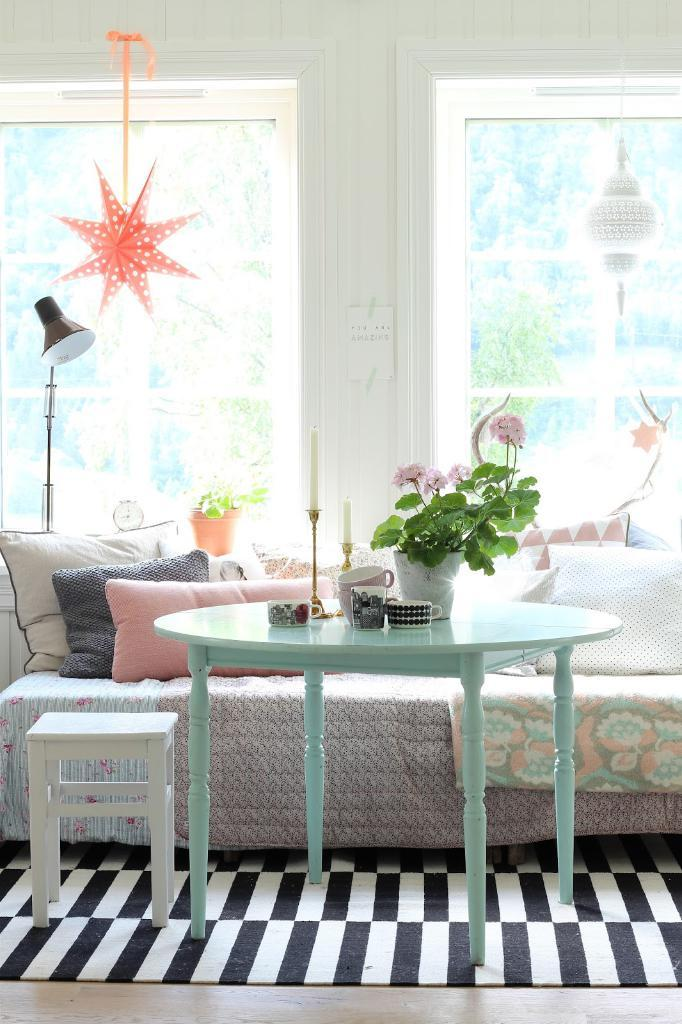What is on the floor in the image? There is a table on the floor in the image. What is on the table? There is a flower pot on the table, and there are objects on the table as well. What can be seen in the background of the image? There is a sofa in the background, and there are pillows on the sofa. What type of door is visible in the image? There is a glass door in the image. How many horses can be seen grazing in the image? There are no horses present in the image. What type of paste is used to stick the objects on the table? There is no paste mentioned or visible in the image; the objects are simply placed on the table. 